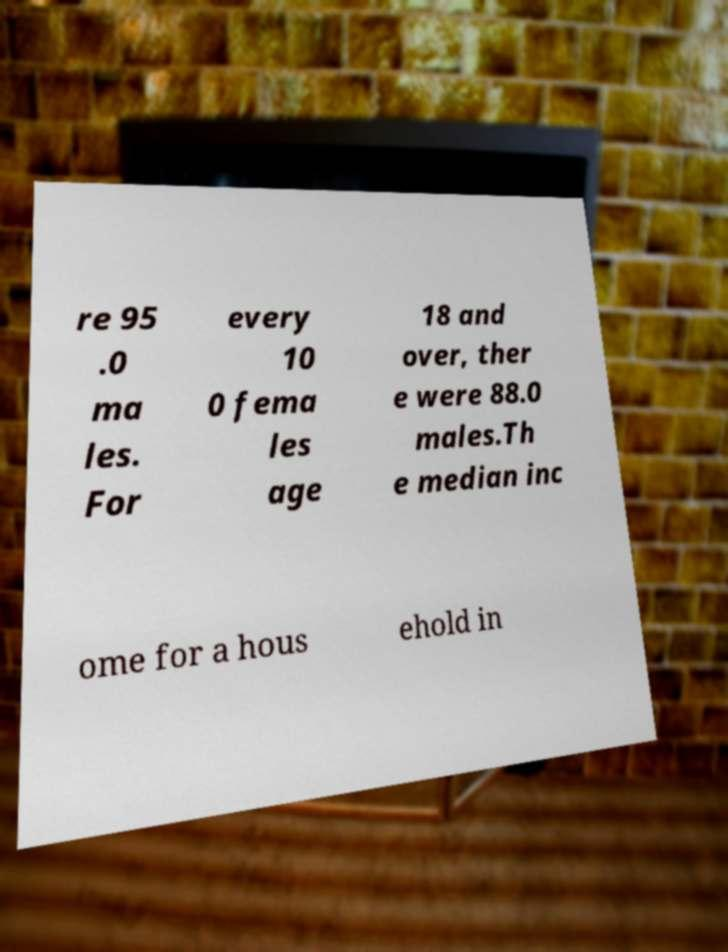There's text embedded in this image that I need extracted. Can you transcribe it verbatim? re 95 .0 ma les. For every 10 0 fema les age 18 and over, ther e were 88.0 males.Th e median inc ome for a hous ehold in 